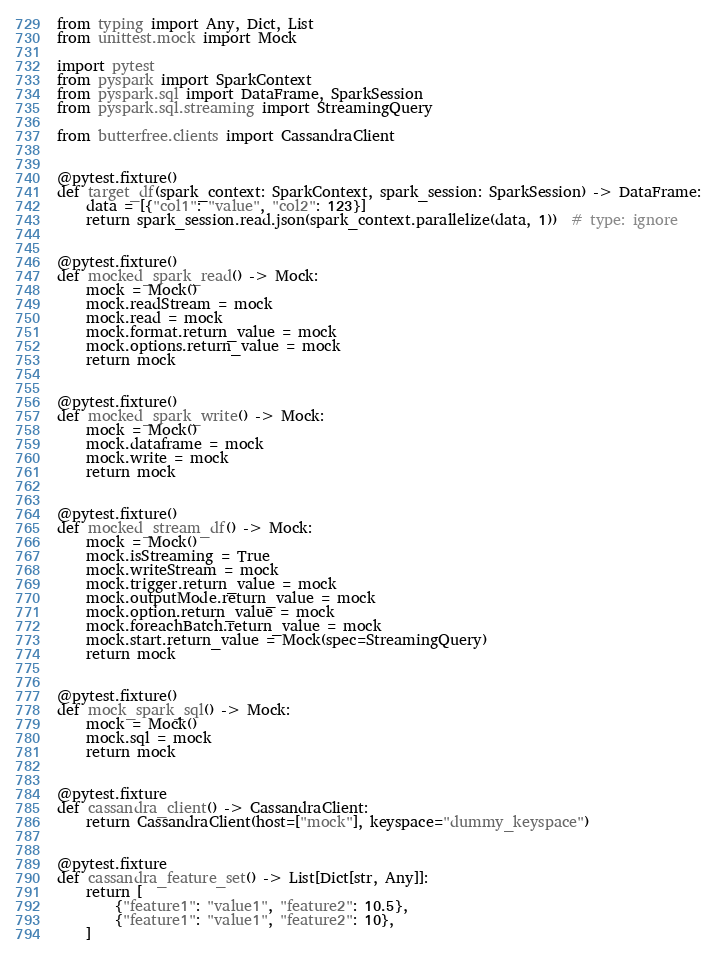<code> <loc_0><loc_0><loc_500><loc_500><_Python_>from typing import Any, Dict, List
from unittest.mock import Mock

import pytest
from pyspark import SparkContext
from pyspark.sql import DataFrame, SparkSession
from pyspark.sql.streaming import StreamingQuery

from butterfree.clients import CassandraClient


@pytest.fixture()
def target_df(spark_context: SparkContext, spark_session: SparkSession) -> DataFrame:
    data = [{"col1": "value", "col2": 123}]
    return spark_session.read.json(spark_context.parallelize(data, 1))  # type: ignore


@pytest.fixture()
def mocked_spark_read() -> Mock:
    mock = Mock()
    mock.readStream = mock
    mock.read = mock
    mock.format.return_value = mock
    mock.options.return_value = mock
    return mock


@pytest.fixture()
def mocked_spark_write() -> Mock:
    mock = Mock()
    mock.dataframe = mock
    mock.write = mock
    return mock


@pytest.fixture()
def mocked_stream_df() -> Mock:
    mock = Mock()
    mock.isStreaming = True
    mock.writeStream = mock
    mock.trigger.return_value = mock
    mock.outputMode.return_value = mock
    mock.option.return_value = mock
    mock.foreachBatch.return_value = mock
    mock.start.return_value = Mock(spec=StreamingQuery)
    return mock


@pytest.fixture()
def mock_spark_sql() -> Mock:
    mock = Mock()
    mock.sql = mock
    return mock


@pytest.fixture
def cassandra_client() -> CassandraClient:
    return CassandraClient(host=["mock"], keyspace="dummy_keyspace")


@pytest.fixture
def cassandra_feature_set() -> List[Dict[str, Any]]:
    return [
        {"feature1": "value1", "feature2": 10.5},
        {"feature1": "value1", "feature2": 10},
    ]
</code> 